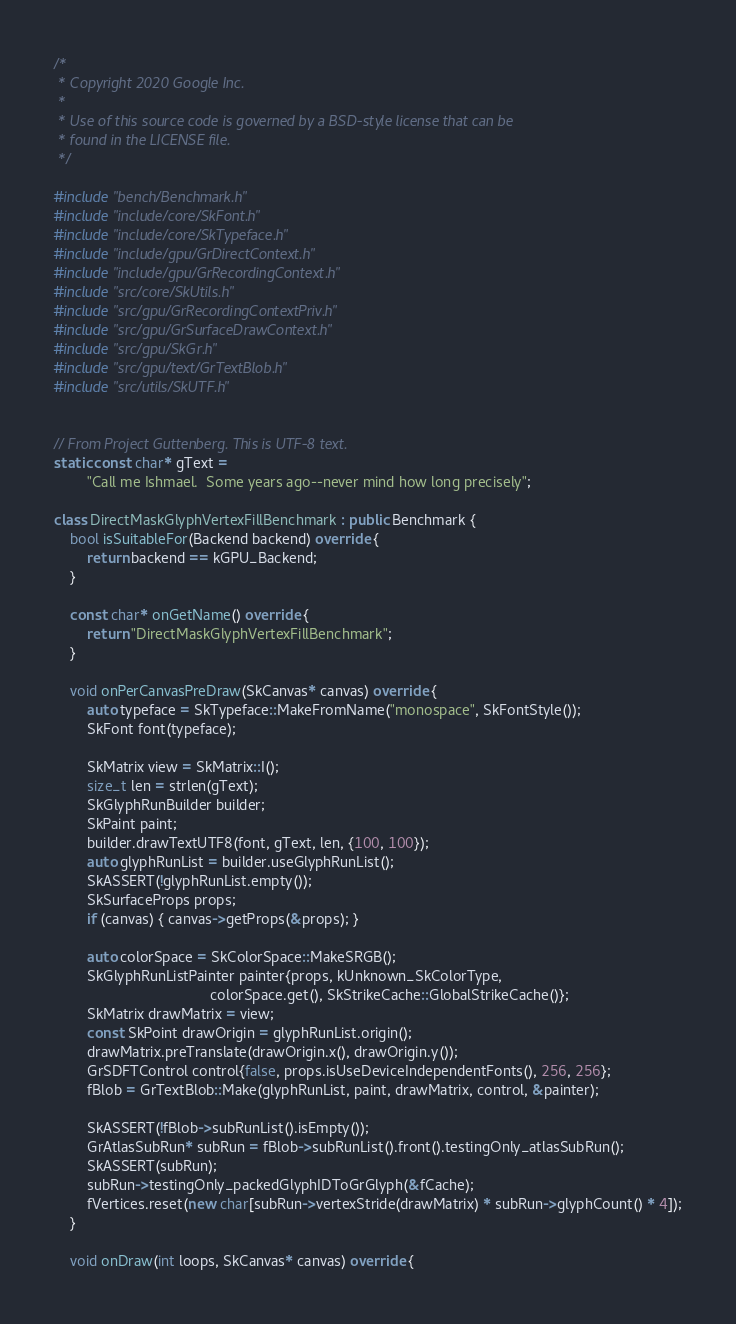Convert code to text. <code><loc_0><loc_0><loc_500><loc_500><_C++_>/*
 * Copyright 2020 Google Inc.
 *
 * Use of this source code is governed by a BSD-style license that can be
 * found in the LICENSE file.
 */

#include "bench/Benchmark.h"
#include "include/core/SkFont.h"
#include "include/core/SkTypeface.h"
#include "include/gpu/GrDirectContext.h"
#include "include/gpu/GrRecordingContext.h"
#include "src/core/SkUtils.h"
#include "src/gpu/GrRecordingContextPriv.h"
#include "src/gpu/GrSurfaceDrawContext.h"
#include "src/gpu/SkGr.h"
#include "src/gpu/text/GrTextBlob.h"
#include "src/utils/SkUTF.h"


// From Project Guttenberg. This is UTF-8 text.
static const char* gText =
        "Call me Ishmael.  Some years ago--never mind how long precisely";

class DirectMaskGlyphVertexFillBenchmark : public Benchmark {
    bool isSuitableFor(Backend backend) override {
        return backend == kGPU_Backend;
    }

    const char* onGetName() override {
        return "DirectMaskGlyphVertexFillBenchmark";
    }

    void onPerCanvasPreDraw(SkCanvas* canvas) override {
        auto typeface = SkTypeface::MakeFromName("monospace", SkFontStyle());
        SkFont font(typeface);

        SkMatrix view = SkMatrix::I();
        size_t len = strlen(gText);
        SkGlyphRunBuilder builder;
        SkPaint paint;
        builder.drawTextUTF8(font, gText, len, {100, 100});
        auto glyphRunList = builder.useGlyphRunList();
        SkASSERT(!glyphRunList.empty());
        SkSurfaceProps props;
        if (canvas) { canvas->getProps(&props); }

        auto colorSpace = SkColorSpace::MakeSRGB();
        SkGlyphRunListPainter painter{props, kUnknown_SkColorType,
                                      colorSpace.get(), SkStrikeCache::GlobalStrikeCache()};
        SkMatrix drawMatrix = view;
        const SkPoint drawOrigin = glyphRunList.origin();
        drawMatrix.preTranslate(drawOrigin.x(), drawOrigin.y());
        GrSDFTControl control{false, props.isUseDeviceIndependentFonts(), 256, 256};
        fBlob = GrTextBlob::Make(glyphRunList, paint, drawMatrix, control, &painter);

        SkASSERT(!fBlob->subRunList().isEmpty());
        GrAtlasSubRun* subRun = fBlob->subRunList().front().testingOnly_atlasSubRun();
        SkASSERT(subRun);
        subRun->testingOnly_packedGlyphIDToGrGlyph(&fCache);
        fVertices.reset(new char[subRun->vertexStride(drawMatrix) * subRun->glyphCount() * 4]);
    }

    void onDraw(int loops, SkCanvas* canvas) override {</code> 